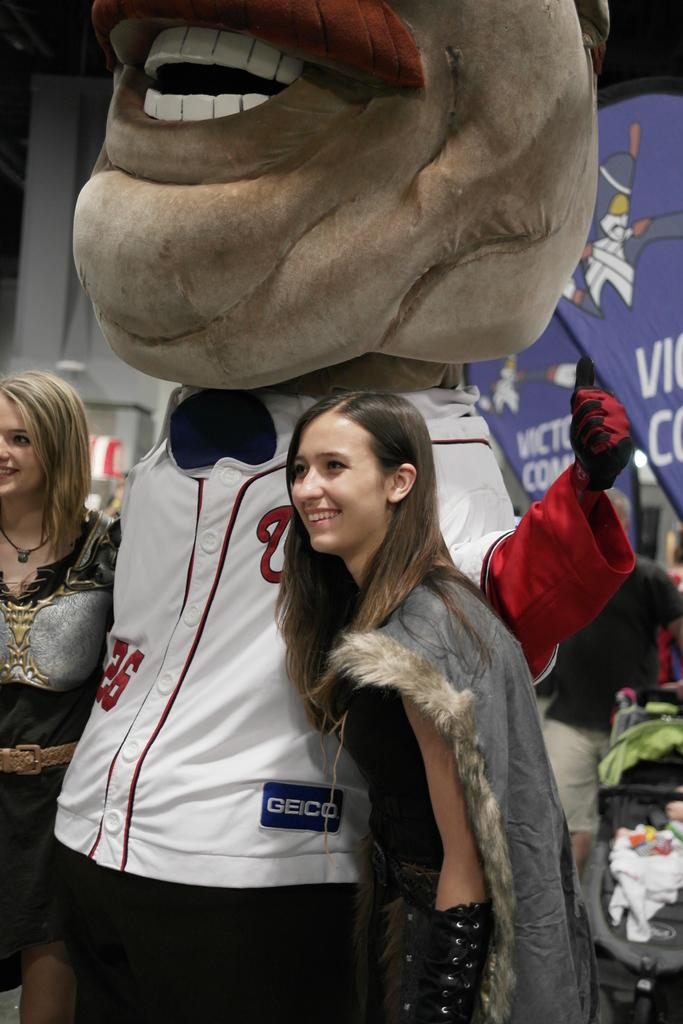Provide a one-sentence caption for the provided image. A large mascot wearing its team jersey sponsored by Geico takes a picture with a young woman. 